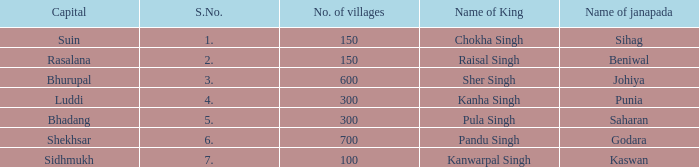What is the average number of villages with a name of janapada of Punia? 300.0. 